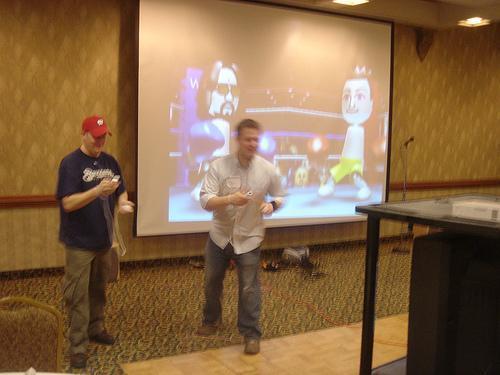How many men?
Give a very brief answer. 2. How many men are in the photo?
Give a very brief answer. 2. 